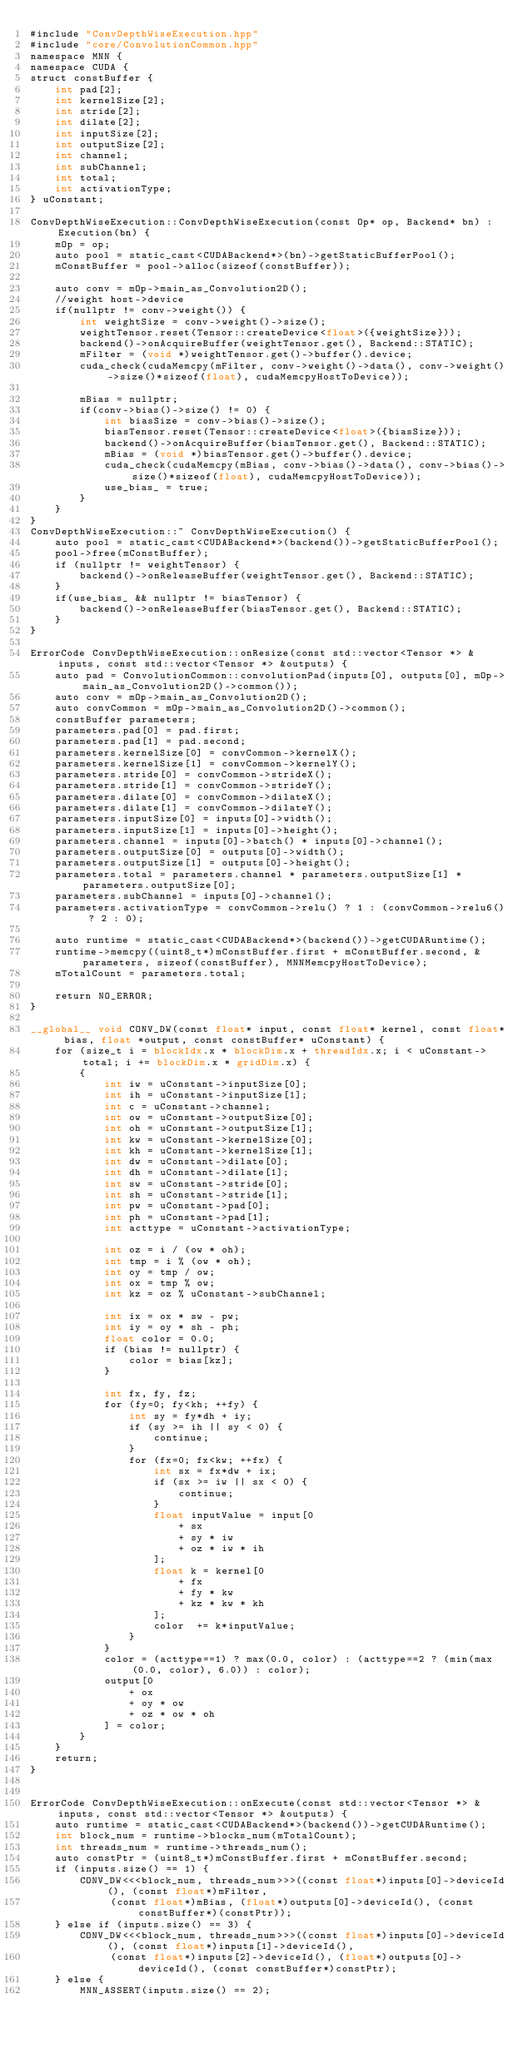<code> <loc_0><loc_0><loc_500><loc_500><_Cuda_>#include "ConvDepthWiseExecution.hpp"
#include "core/ConvolutionCommon.hpp"
namespace MNN {
namespace CUDA {
struct constBuffer {
    int pad[2];
    int kernelSize[2];
    int stride[2];
    int dilate[2];
    int inputSize[2];
    int outputSize[2];
    int channel;
    int subChannel;
    int total;
    int activationType;
} uConstant;

ConvDepthWiseExecution::ConvDepthWiseExecution(const Op* op, Backend* bn) : Execution(bn) {
    mOp = op;
    auto pool = static_cast<CUDABackend*>(bn)->getStaticBufferPool();
    mConstBuffer = pool->alloc(sizeof(constBuffer));

    auto conv = mOp->main_as_Convolution2D();
    //weight host->device
    if(nullptr != conv->weight()) {
        int weightSize = conv->weight()->size();
        weightTensor.reset(Tensor::createDevice<float>({weightSize}));
        backend()->onAcquireBuffer(weightTensor.get(), Backend::STATIC);
        mFilter = (void *)weightTensor.get()->buffer().device;
        cuda_check(cudaMemcpy(mFilter, conv->weight()->data(), conv->weight()->size()*sizeof(float), cudaMemcpyHostToDevice));

        mBias = nullptr;
        if(conv->bias()->size() != 0) {
            int biasSize = conv->bias()->size();
            biasTensor.reset(Tensor::createDevice<float>({biasSize}));
            backend()->onAcquireBuffer(biasTensor.get(), Backend::STATIC);
            mBias = (void *)biasTensor.get()->buffer().device;
            cuda_check(cudaMemcpy(mBias, conv->bias()->data(), conv->bias()->size()*sizeof(float), cudaMemcpyHostToDevice));
            use_bias_ = true;
        }
    }
}
ConvDepthWiseExecution::~ ConvDepthWiseExecution() {
    auto pool = static_cast<CUDABackend*>(backend())->getStaticBufferPool();
    pool->free(mConstBuffer);
    if (nullptr != weightTensor) {
        backend()->onReleaseBuffer(weightTensor.get(), Backend::STATIC);
    }
    if(use_bias_ && nullptr != biasTensor) {
        backend()->onReleaseBuffer(biasTensor.get(), Backend::STATIC);
    }
}

ErrorCode ConvDepthWiseExecution::onResize(const std::vector<Tensor *> &inputs, const std::vector<Tensor *> &outputs) {
    auto pad = ConvolutionCommon::convolutionPad(inputs[0], outputs[0], mOp->main_as_Convolution2D()->common());
    auto conv = mOp->main_as_Convolution2D();
    auto convCommon = mOp->main_as_Convolution2D()->common();
    constBuffer parameters;
    parameters.pad[0] = pad.first;
    parameters.pad[1] = pad.second;
    parameters.kernelSize[0] = convCommon->kernelX();
    parameters.kernelSize[1] = convCommon->kernelY();
    parameters.stride[0] = convCommon->strideX();
    parameters.stride[1] = convCommon->strideY();
    parameters.dilate[0] = convCommon->dilateX();
    parameters.dilate[1] = convCommon->dilateY();
    parameters.inputSize[0] = inputs[0]->width();
    parameters.inputSize[1] = inputs[0]->height();
    parameters.channel = inputs[0]->batch() * inputs[0]->channel();
    parameters.outputSize[0] = outputs[0]->width();
    parameters.outputSize[1] = outputs[0]->height();
    parameters.total = parameters.channel * parameters.outputSize[1] * parameters.outputSize[0];
    parameters.subChannel = inputs[0]->channel();
    parameters.activationType = convCommon->relu() ? 1 : (convCommon->relu6() ? 2 : 0);

    auto runtime = static_cast<CUDABackend*>(backend())->getCUDARuntime();
    runtime->memcpy((uint8_t*)mConstBuffer.first + mConstBuffer.second, &parameters, sizeof(constBuffer), MNNMemcpyHostToDevice);
    mTotalCount = parameters.total;

    return NO_ERROR;
}

__global__ void CONV_DW(const float* input, const float* kernel, const float* bias, float *output, const constBuffer* uConstant) {
    for (size_t i = blockIdx.x * blockDim.x + threadIdx.x; i < uConstant->total; i += blockDim.x * gridDim.x) {
        {
            int iw = uConstant->inputSize[0];
            int ih = uConstant->inputSize[1];
            int c = uConstant->channel;
            int ow = uConstant->outputSize[0];
            int oh = uConstant->outputSize[1];
            int kw = uConstant->kernelSize[0];
            int kh = uConstant->kernelSize[1];
            int dw = uConstant->dilate[0];
            int dh = uConstant->dilate[1];
            int sw = uConstant->stride[0];
            int sh = uConstant->stride[1];
            int pw = uConstant->pad[0];
            int ph = uConstant->pad[1];
            int acttype = uConstant->activationType;

            int oz = i / (ow * oh);
            int tmp = i % (ow * oh);
            int oy = tmp / ow;
            int ox = tmp % ow;
            int kz = oz % uConstant->subChannel;
            
            int ix = ox * sw - pw;
            int iy = oy * sh - ph;
            float color = 0.0;
            if (bias != nullptr) {
                color = bias[kz];
            }

            int fx, fy, fz;
            for (fy=0; fy<kh; ++fy) {
                int sy = fy*dh + iy;
                if (sy >= ih || sy < 0) {
                    continue;
                }
                for (fx=0; fx<kw; ++fx) {
                    int sx = fx*dw + ix;
                    if (sx >= iw || sx < 0) {
                        continue;
                    }
                    float inputValue = input[0
                        + sx
                        + sy * iw
                        + oz * iw * ih
                    ];
                    float k = kernel[0
                        + fx
                        + fy * kw
                        + kz * kw * kh
                    ];
                    color  += k*inputValue;
                }
            }
            color = (acttype==1) ? max(0.0, color) : (acttype==2 ? (min(max(0.0, color), 6.0)) : color);
            output[0
                + ox
                + oy * ow
                + oz * ow * oh
            ] = color;
        }
    }
    return;
}


ErrorCode ConvDepthWiseExecution::onExecute(const std::vector<Tensor *> &inputs, const std::vector<Tensor *> &outputs) {
    auto runtime = static_cast<CUDABackend*>(backend())->getCUDARuntime();
    int block_num = runtime->blocks_num(mTotalCount);
    int threads_num = runtime->threads_num();
    auto constPtr = (uint8_t*)mConstBuffer.first + mConstBuffer.second;
    if (inputs.size() == 1) {
        CONV_DW<<<block_num, threads_num>>>((const float*)inputs[0]->deviceId(), (const float*)mFilter,
             (const float*)mBias, (float*)outputs[0]->deviceId(), (const constBuffer*)(constPtr));
    } else if (inputs.size() == 3) {
        CONV_DW<<<block_num, threads_num>>>((const float*)inputs[0]->deviceId(), (const float*)inputs[1]->deviceId(),
             (const float*)inputs[2]->deviceId(), (float*)outputs[0]->deviceId(), (const constBuffer*)constPtr);
    } else {
        MNN_ASSERT(inputs.size() == 2);</code> 